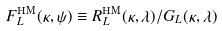<formula> <loc_0><loc_0><loc_500><loc_500>F ^ { \text {HM} } _ { L } ( \kappa , \psi ) \equiv R ^ { \text {HM} } _ { L } ( \kappa , \lambda ) / G _ { L } ( \kappa , \lambda )</formula> 